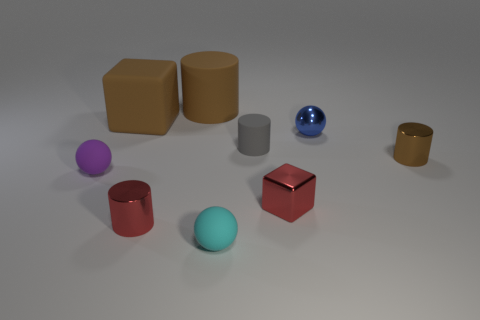There is a red shiny object that is in front of the red object that is to the right of the big matte cylinder; what shape is it? The red shiny object in question appears to be a cube. It's positioned in front of another red object, which is cylindrical in shape and situated to the right of the larger, matte-finished cylinder. 